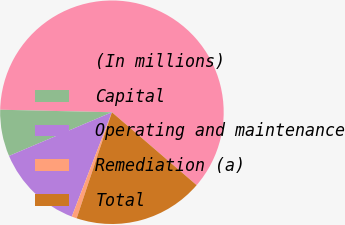Convert chart to OTSL. <chart><loc_0><loc_0><loc_500><loc_500><pie_chart><fcel>(In millions)<fcel>Capital<fcel>Operating and maintenance<fcel>Remediation (a)<fcel>Total<nl><fcel>60.95%<fcel>6.75%<fcel>12.77%<fcel>0.73%<fcel>18.8%<nl></chart> 